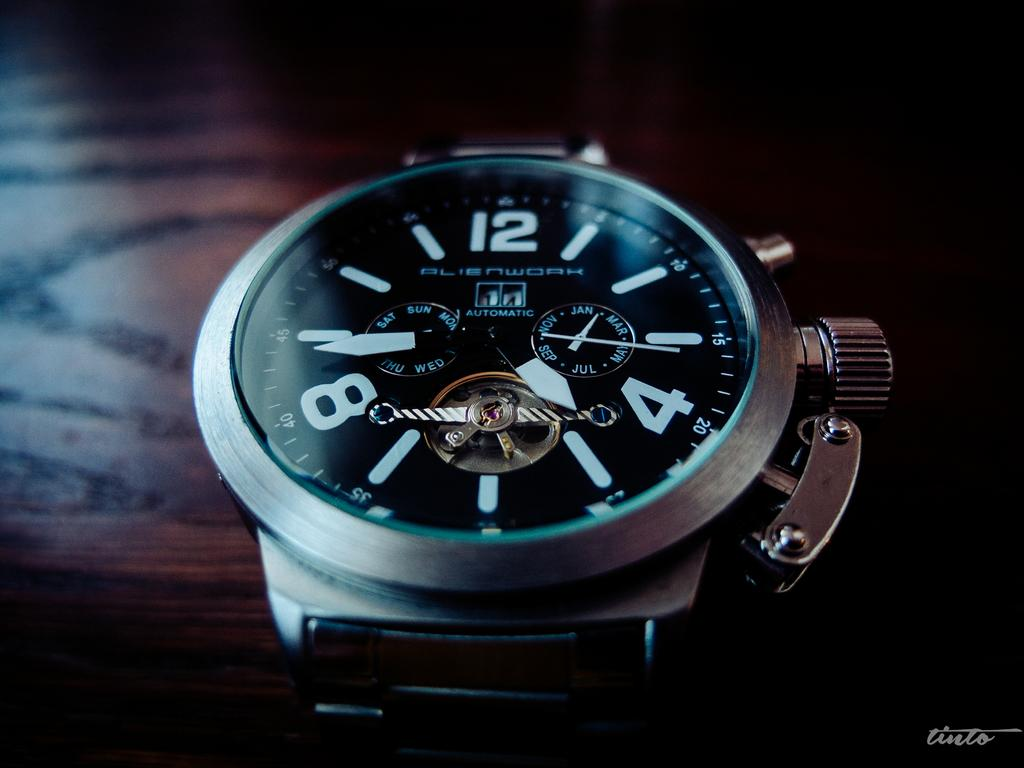Provide a one-sentence caption for the provided image. Face of a watch which says Alienwork on the screen. 